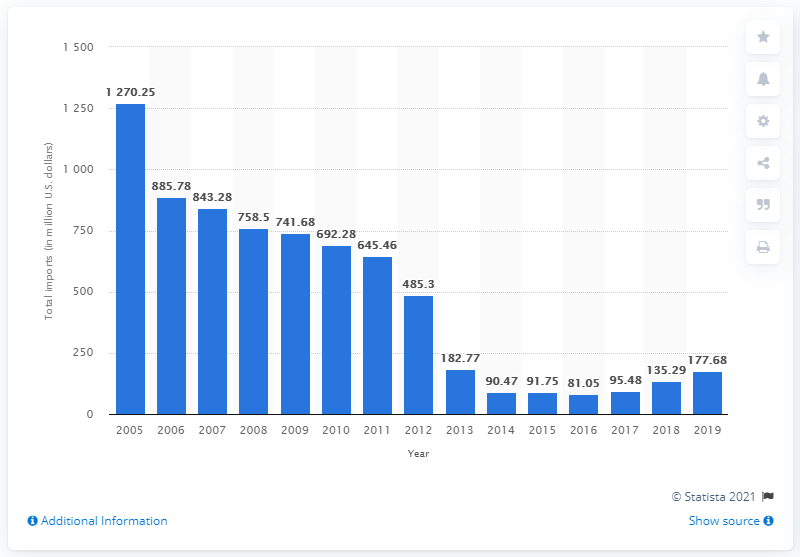Specify some key components in this picture. In 2019, the total value of merchandise imported to the United States from Japan was 177.68 billion dollars. 